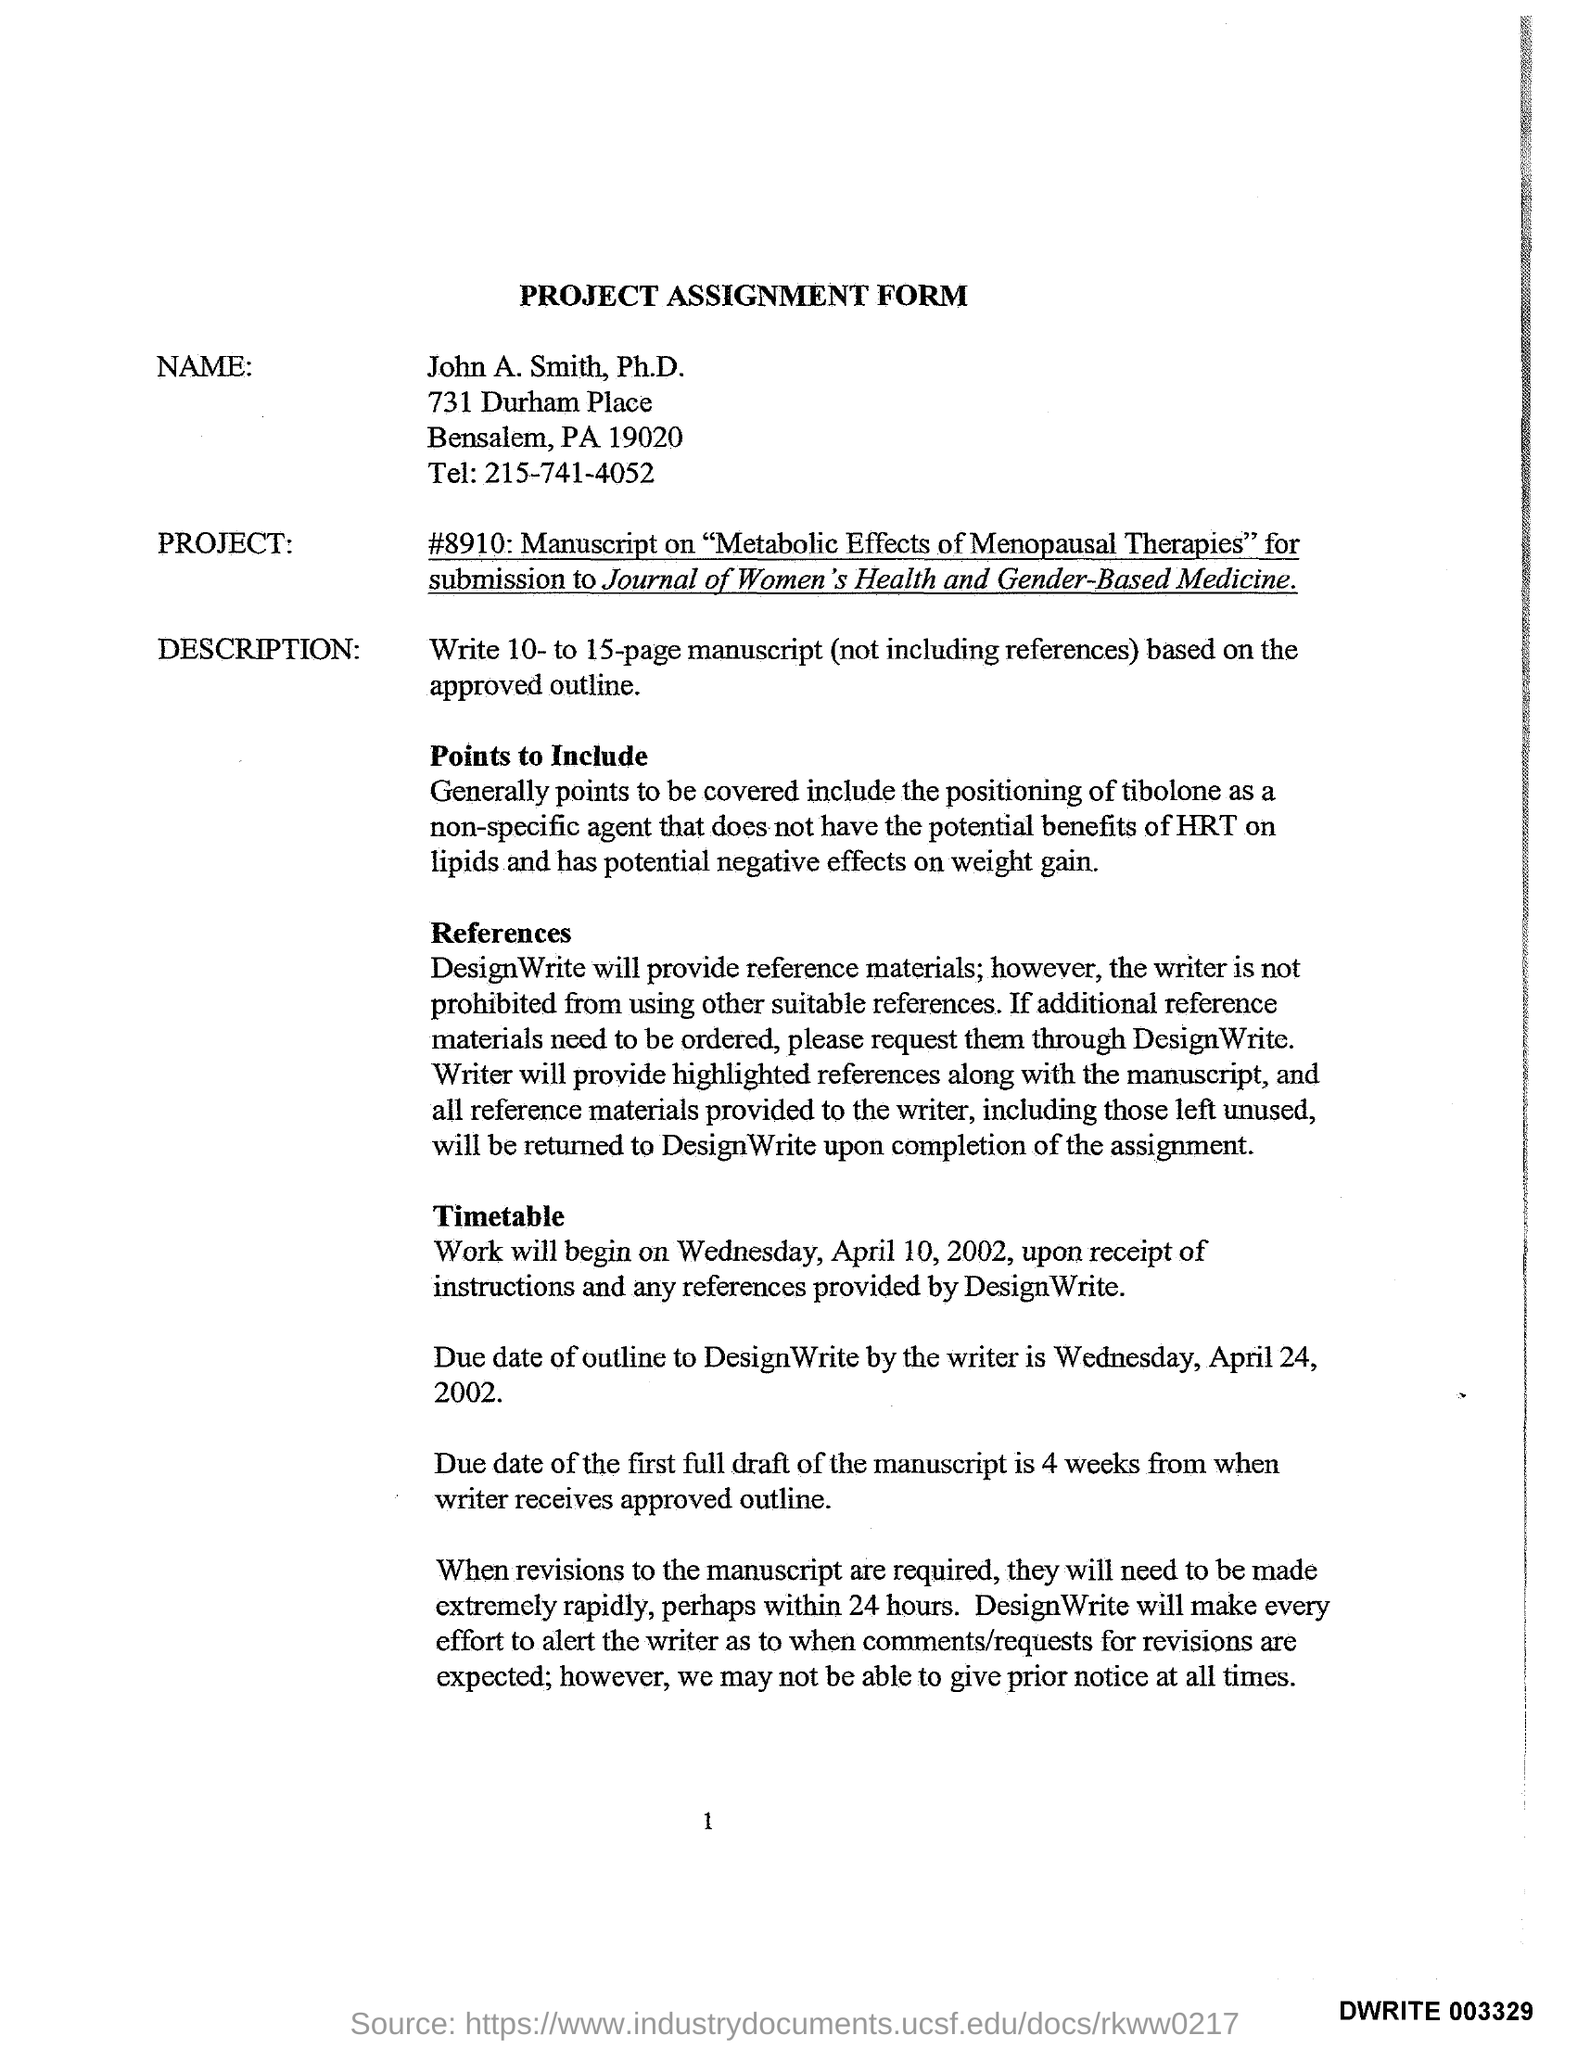Indicate a few pertinent items in this graphic. The heading of this document is 'PROJECT ASSIGNMENT FORM.' The individual's name is John A. Smith. 